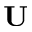Convert formula to latex. <formula><loc_0><loc_0><loc_500><loc_500>U</formula> 